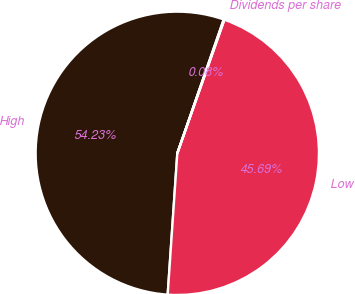Convert chart to OTSL. <chart><loc_0><loc_0><loc_500><loc_500><pie_chart><fcel>High<fcel>Low<fcel>Dividends per share<nl><fcel>54.23%<fcel>45.69%<fcel>0.08%<nl></chart> 